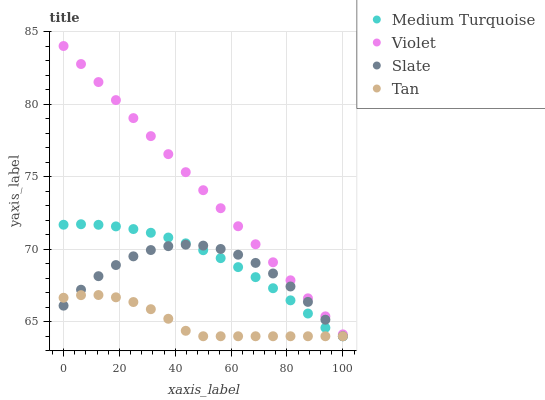Does Tan have the minimum area under the curve?
Answer yes or no. Yes. Does Violet have the maximum area under the curve?
Answer yes or no. Yes. Does Medium Turquoise have the minimum area under the curve?
Answer yes or no. No. Does Medium Turquoise have the maximum area under the curve?
Answer yes or no. No. Is Violet the smoothest?
Answer yes or no. Yes. Is Slate the roughest?
Answer yes or no. Yes. Is Tan the smoothest?
Answer yes or no. No. Is Tan the roughest?
Answer yes or no. No. Does Slate have the lowest value?
Answer yes or no. Yes. Does Violet have the lowest value?
Answer yes or no. No. Does Violet have the highest value?
Answer yes or no. Yes. Does Medium Turquoise have the highest value?
Answer yes or no. No. Is Slate less than Violet?
Answer yes or no. Yes. Is Violet greater than Tan?
Answer yes or no. Yes. Does Slate intersect Tan?
Answer yes or no. Yes. Is Slate less than Tan?
Answer yes or no. No. Is Slate greater than Tan?
Answer yes or no. No. Does Slate intersect Violet?
Answer yes or no. No. 